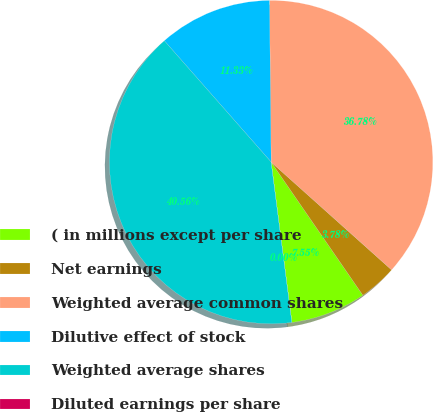Convert chart to OTSL. <chart><loc_0><loc_0><loc_500><loc_500><pie_chart><fcel>( in millions except per share<fcel>Net earnings<fcel>Weighted average common shares<fcel>Dilutive effect of stock<fcel>Weighted average shares<fcel>Diluted earnings per share<nl><fcel>7.55%<fcel>3.78%<fcel>36.78%<fcel>11.33%<fcel>40.56%<fcel>0.0%<nl></chart> 